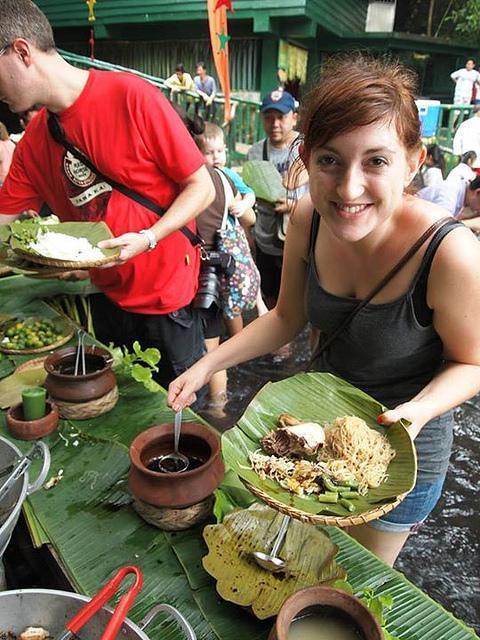How many bowls are there?
Give a very brief answer. 3. How many people are in the picture?
Give a very brief answer. 4. 